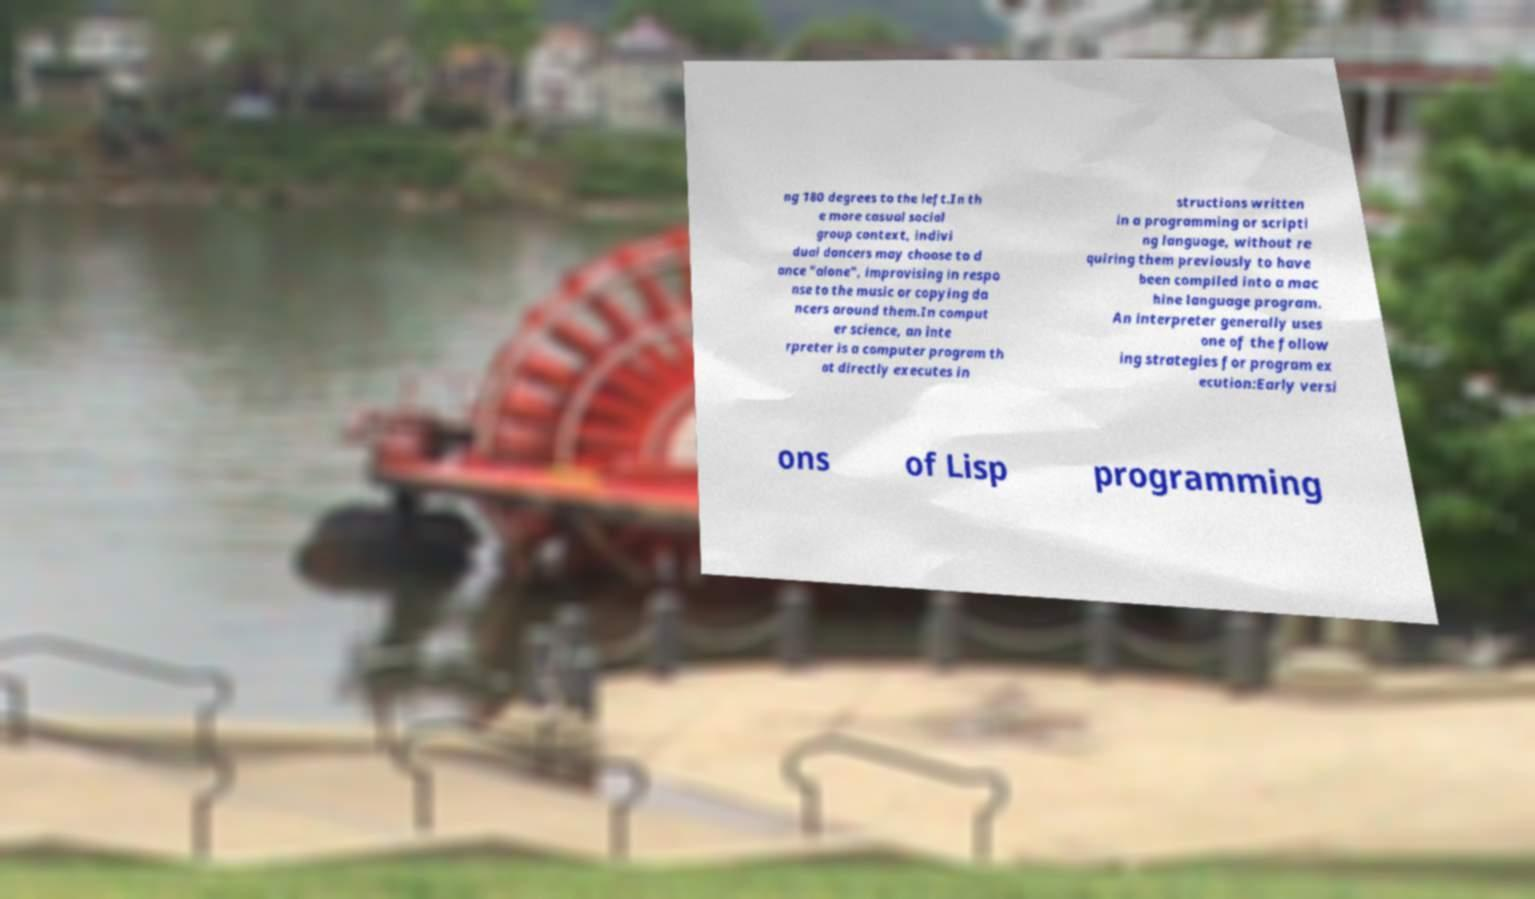Could you assist in decoding the text presented in this image and type it out clearly? ng 180 degrees to the left.In th e more casual social group context, indivi dual dancers may choose to d ance "alone", improvising in respo nse to the music or copying da ncers around them.In comput er science, an inte rpreter is a computer program th at directly executes in structions written in a programming or scripti ng language, without re quiring them previously to have been compiled into a mac hine language program. An interpreter generally uses one of the follow ing strategies for program ex ecution:Early versi ons of Lisp programming 